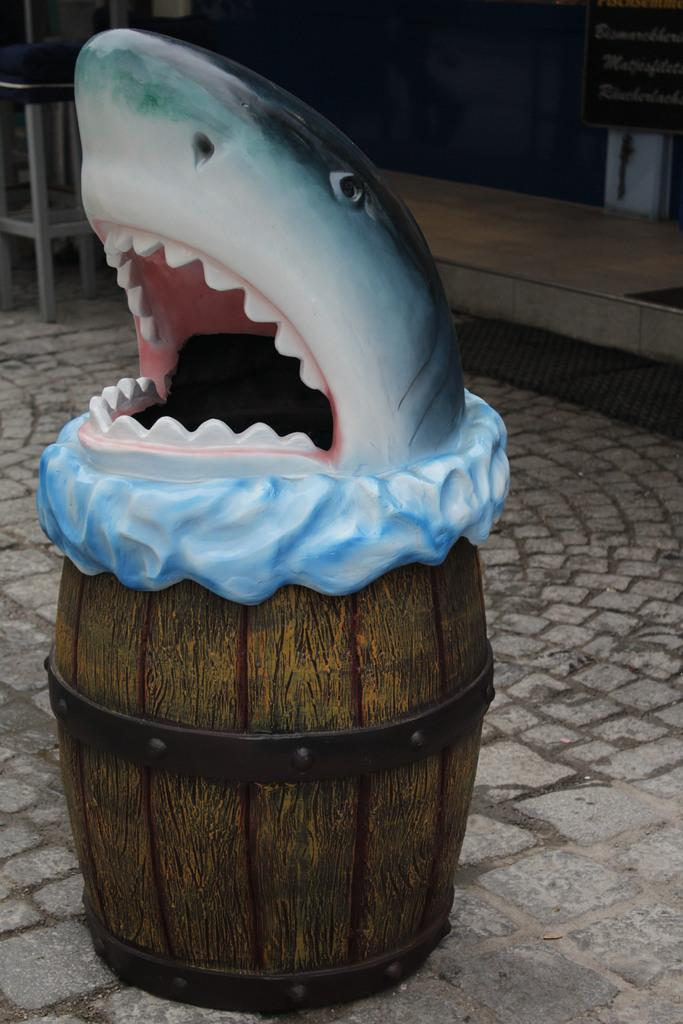What is the main subject of the image? The main subject of the image is a container. What is unique about the container? The container is a sculpture of a shark. What can be seen in the background of the image? There is a footpath and a board visible in the image. Are there any other objects in the image besides the container? Yes, there are other objects in the image. How many pigs are present in the image? There are no pigs present in the image. What role does the son play in the image? There is no son present in the image, so it is not possible to determine any role. 